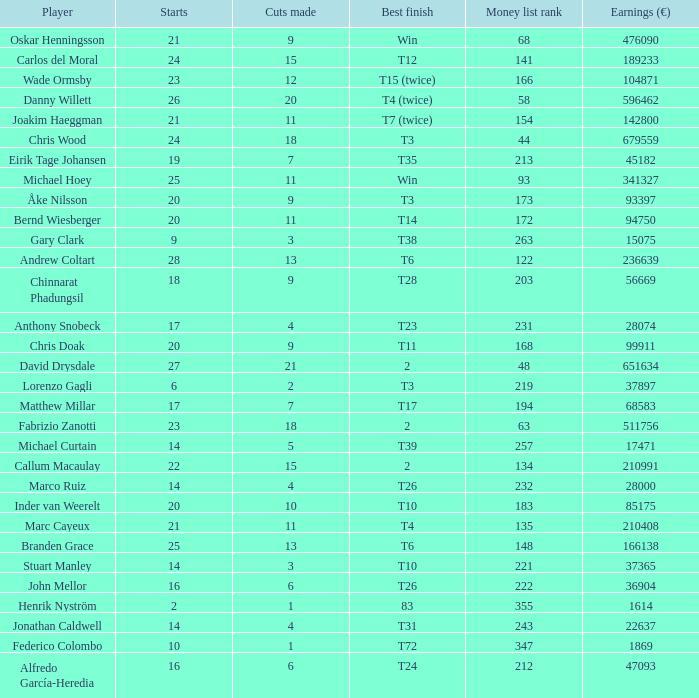How many cuts did Gary Clark make? 3.0. 